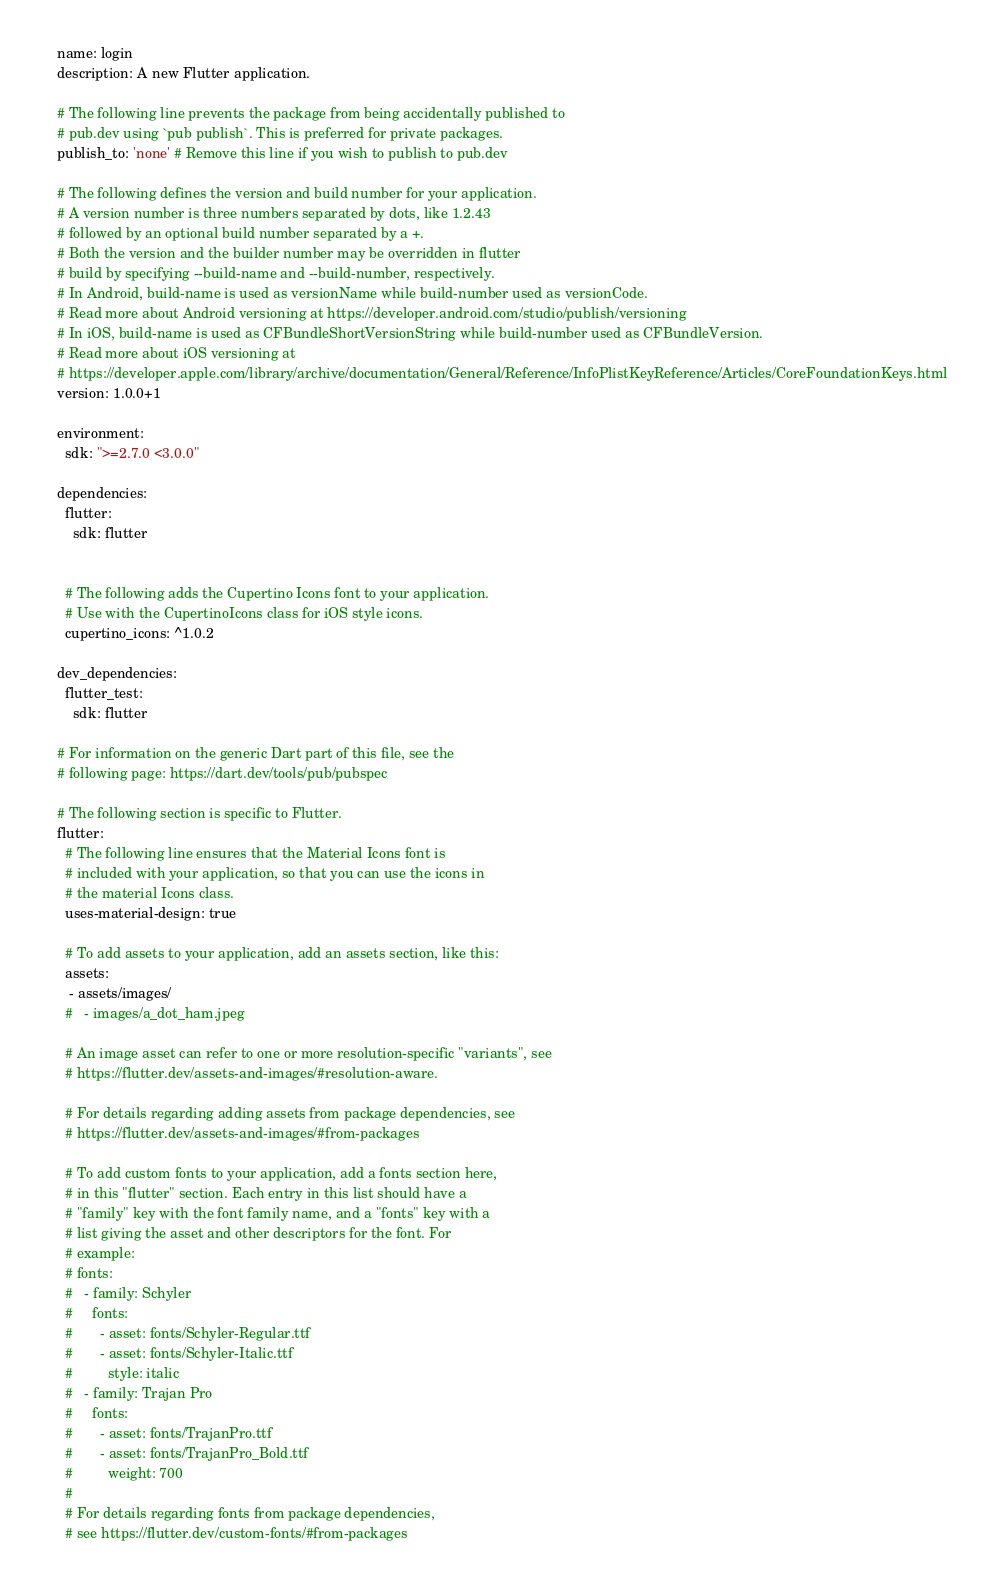<code> <loc_0><loc_0><loc_500><loc_500><_YAML_>name: login
description: A new Flutter application.

# The following line prevents the package from being accidentally published to
# pub.dev using `pub publish`. This is preferred for private packages.
publish_to: 'none' # Remove this line if you wish to publish to pub.dev

# The following defines the version and build number for your application.
# A version number is three numbers separated by dots, like 1.2.43
# followed by an optional build number separated by a +.
# Both the version and the builder number may be overridden in flutter
# build by specifying --build-name and --build-number, respectively.
# In Android, build-name is used as versionName while build-number used as versionCode.
# Read more about Android versioning at https://developer.android.com/studio/publish/versioning
# In iOS, build-name is used as CFBundleShortVersionString while build-number used as CFBundleVersion.
# Read more about iOS versioning at
# https://developer.apple.com/library/archive/documentation/General/Reference/InfoPlistKeyReference/Articles/CoreFoundationKeys.html
version: 1.0.0+1

environment:
  sdk: ">=2.7.0 <3.0.0"

dependencies:
  flutter:
    sdk: flutter


  # The following adds the Cupertino Icons font to your application.
  # Use with the CupertinoIcons class for iOS style icons.
  cupertino_icons: ^1.0.2

dev_dependencies:
  flutter_test:
    sdk: flutter

# For information on the generic Dart part of this file, see the
# following page: https://dart.dev/tools/pub/pubspec

# The following section is specific to Flutter.
flutter:
  # The following line ensures that the Material Icons font is
  # included with your application, so that you can use the icons in
  # the material Icons class.
  uses-material-design: true

  # To add assets to your application, add an assets section, like this:
  assets:
   - assets/images/
  #   - images/a_dot_ham.jpeg

  # An image asset can refer to one or more resolution-specific "variants", see
  # https://flutter.dev/assets-and-images/#resolution-aware.

  # For details regarding adding assets from package dependencies, see
  # https://flutter.dev/assets-and-images/#from-packages

  # To add custom fonts to your application, add a fonts section here,
  # in this "flutter" section. Each entry in this list should have a
  # "family" key with the font family name, and a "fonts" key with a
  # list giving the asset and other descriptors for the font. For
  # example:
  # fonts:
  #   - family: Schyler
  #     fonts:
  #       - asset: fonts/Schyler-Regular.ttf
  #       - asset: fonts/Schyler-Italic.ttf
  #         style: italic
  #   - family: Trajan Pro
  #     fonts:
  #       - asset: fonts/TrajanPro.ttf
  #       - asset: fonts/TrajanPro_Bold.ttf
  #         weight: 700
  #
  # For details regarding fonts from package dependencies,
  # see https://flutter.dev/custom-fonts/#from-packages
</code> 